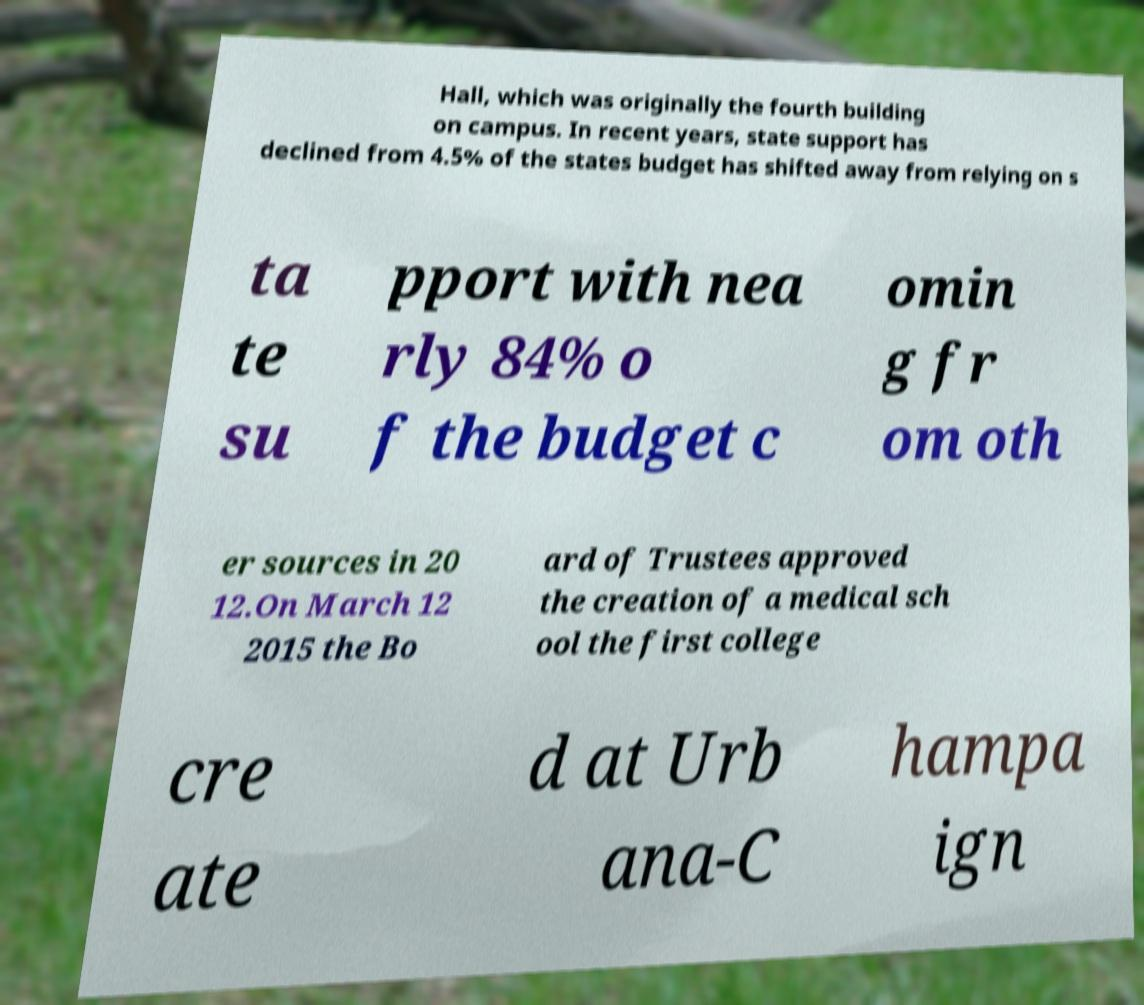Could you extract and type out the text from this image? Hall, which was originally the fourth building on campus. In recent years, state support has declined from 4.5% of the states budget has shifted away from relying on s ta te su pport with nea rly 84% o f the budget c omin g fr om oth er sources in 20 12.On March 12 2015 the Bo ard of Trustees approved the creation of a medical sch ool the first college cre ate d at Urb ana-C hampa ign 